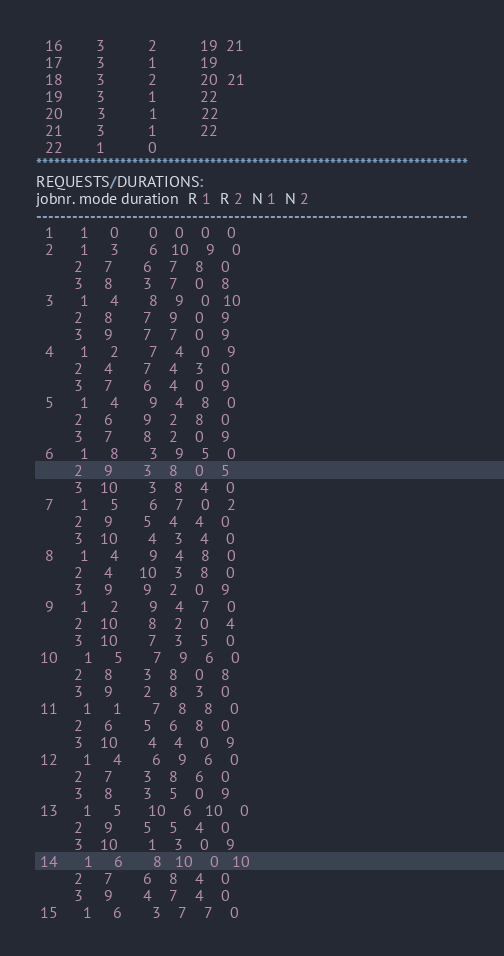<code> <loc_0><loc_0><loc_500><loc_500><_ObjectiveC_>  16        3          2          19  21
  17        3          1          19
  18        3          2          20  21
  19        3          1          22
  20        3          1          22
  21        3          1          22
  22        1          0        
************************************************************************
REQUESTS/DURATIONS:
jobnr. mode duration  R 1  R 2  N 1  N 2
------------------------------------------------------------------------
  1      1     0       0    0    0    0
  2      1     3       6   10    9    0
         2     7       6    7    8    0
         3     8       3    7    0    8
  3      1     4       8    9    0   10
         2     8       7    9    0    9
         3     9       7    7    0    9
  4      1     2       7    4    0    9
         2     4       7    4    3    0
         3     7       6    4    0    9
  5      1     4       9    4    8    0
         2     6       9    2    8    0
         3     7       8    2    0    9
  6      1     8       3    9    5    0
         2     9       3    8    0    5
         3    10       3    8    4    0
  7      1     5       6    7    0    2
         2     9       5    4    4    0
         3    10       4    3    4    0
  8      1     4       9    4    8    0
         2     4      10    3    8    0
         3     9       9    2    0    9
  9      1     2       9    4    7    0
         2    10       8    2    0    4
         3    10       7    3    5    0
 10      1     5       7    9    6    0
         2     8       3    8    0    8
         3     9       2    8    3    0
 11      1     1       7    8    8    0
         2     6       5    6    8    0
         3    10       4    4    0    9
 12      1     4       6    9    6    0
         2     7       3    8    6    0
         3     8       3    5    0    9
 13      1     5      10    6   10    0
         2     9       5    5    4    0
         3    10       1    3    0    9
 14      1     6       8   10    0   10
         2     7       6    8    4    0
         3     9       4    7    4    0
 15      1     6       3    7    7    0</code> 